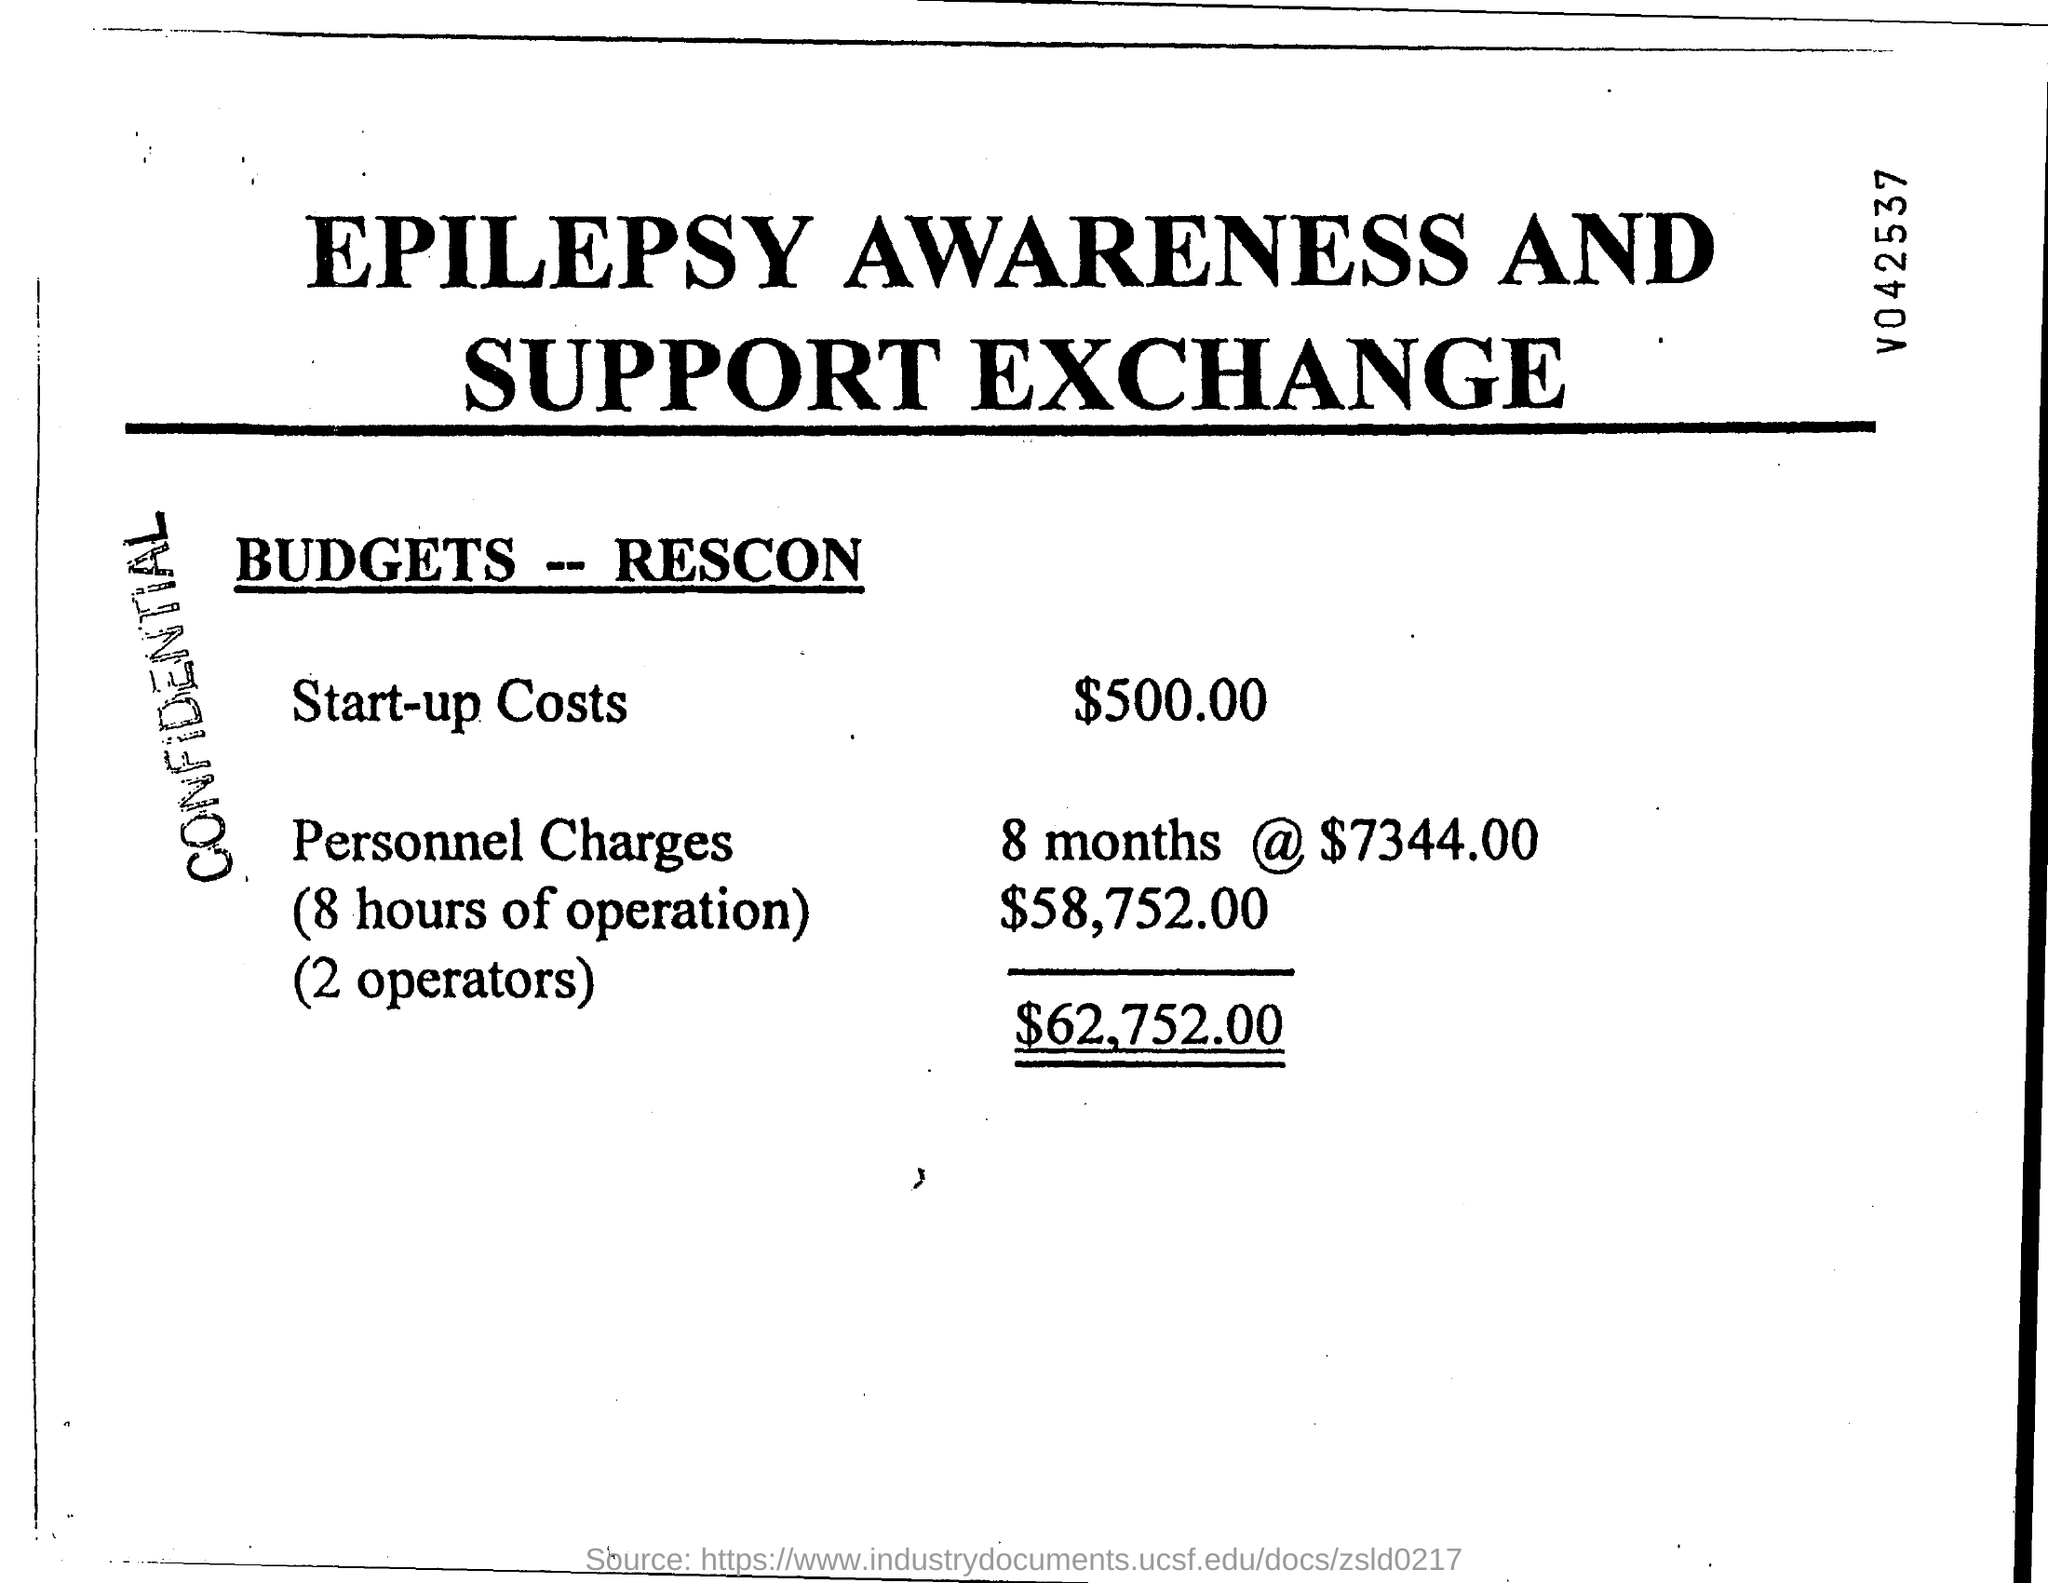Mention a couple of crucial points in this snapshot. Start-up costs refer to the initial expenses incurred to establish a business, which typically include items such as equipment, inventory, and other necessary items. In this case, the start-up costs for the business are estimated to be $500.00. The total budget for the project is $62,752.00. 